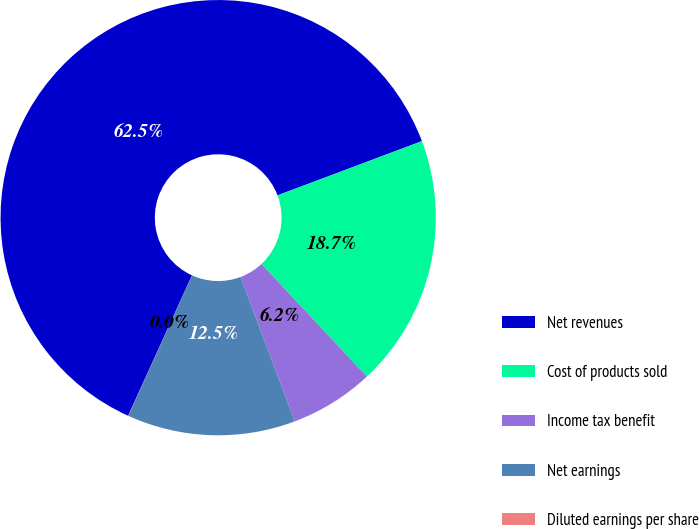<chart> <loc_0><loc_0><loc_500><loc_500><pie_chart><fcel>Net revenues<fcel>Cost of products sold<fcel>Income tax benefit<fcel>Net earnings<fcel>Diluted earnings per share<nl><fcel>62.49%<fcel>18.75%<fcel>6.25%<fcel>12.5%<fcel>0.01%<nl></chart> 